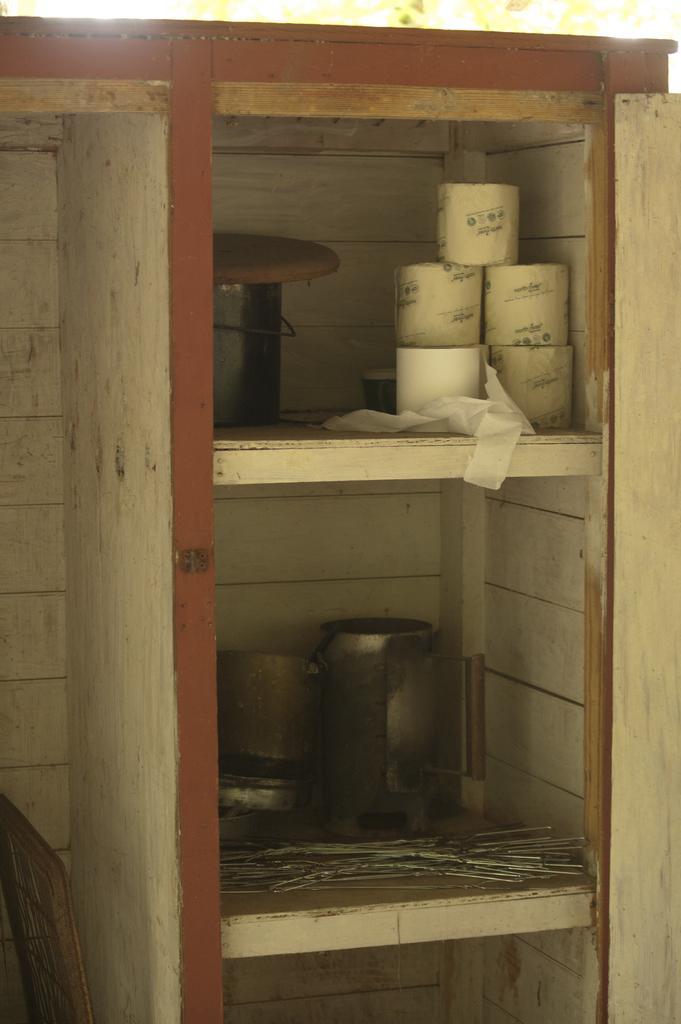Describe this image in one or two sentences. In this picture we can see tissue papers, steel bowl and other objects on this rack. On the left we can see wooden wall. On the top we can see tree. 